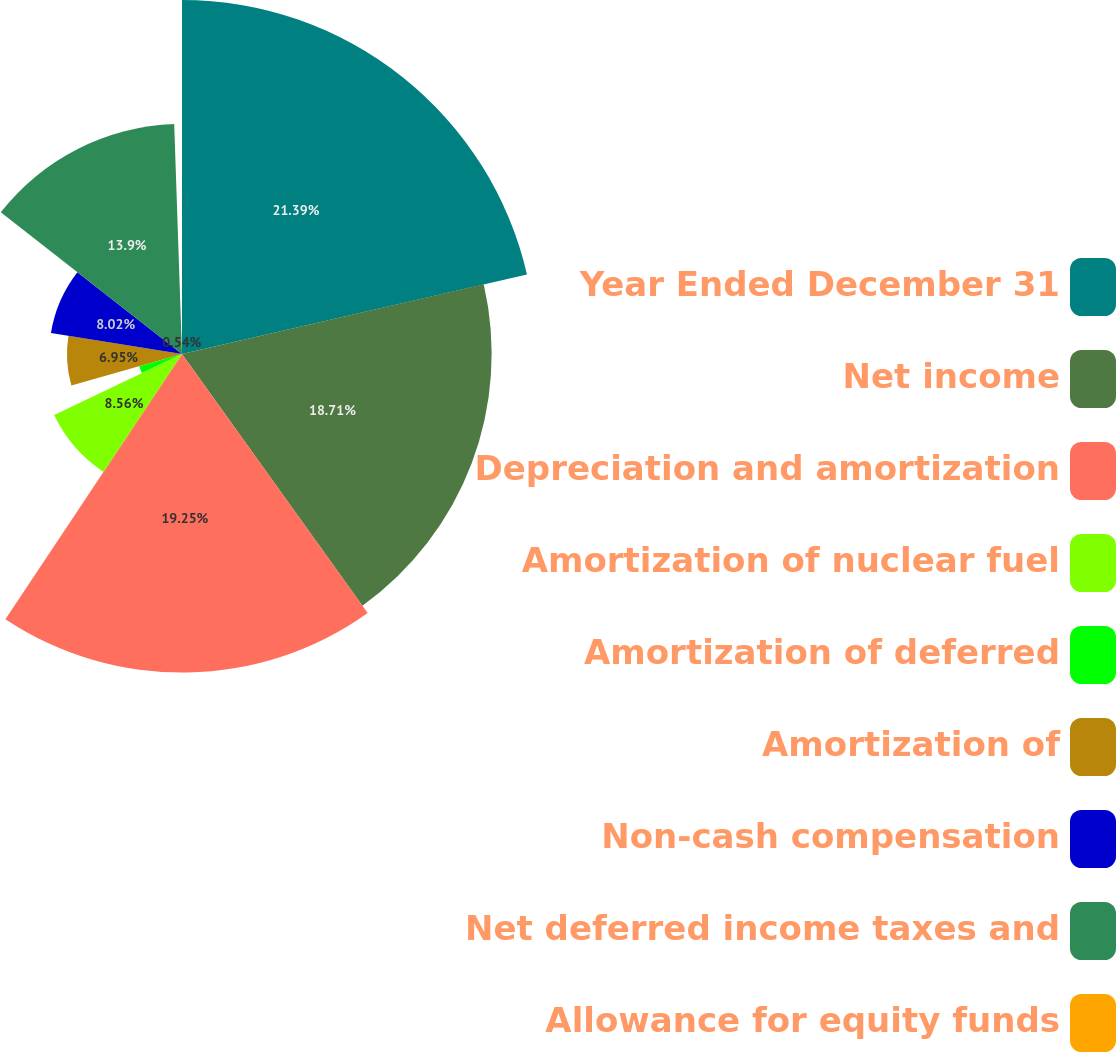Convert chart. <chart><loc_0><loc_0><loc_500><loc_500><pie_chart><fcel>Year Ended December 31<fcel>Net income<fcel>Depreciation and amortization<fcel>Amortization of nuclear fuel<fcel>Amortization of deferred<fcel>Amortization of<fcel>Non-cash compensation<fcel>Net deferred income taxes and<fcel>Allowance for equity funds<nl><fcel>21.39%<fcel>18.71%<fcel>19.25%<fcel>8.56%<fcel>2.68%<fcel>6.95%<fcel>8.02%<fcel>13.9%<fcel>0.54%<nl></chart> 